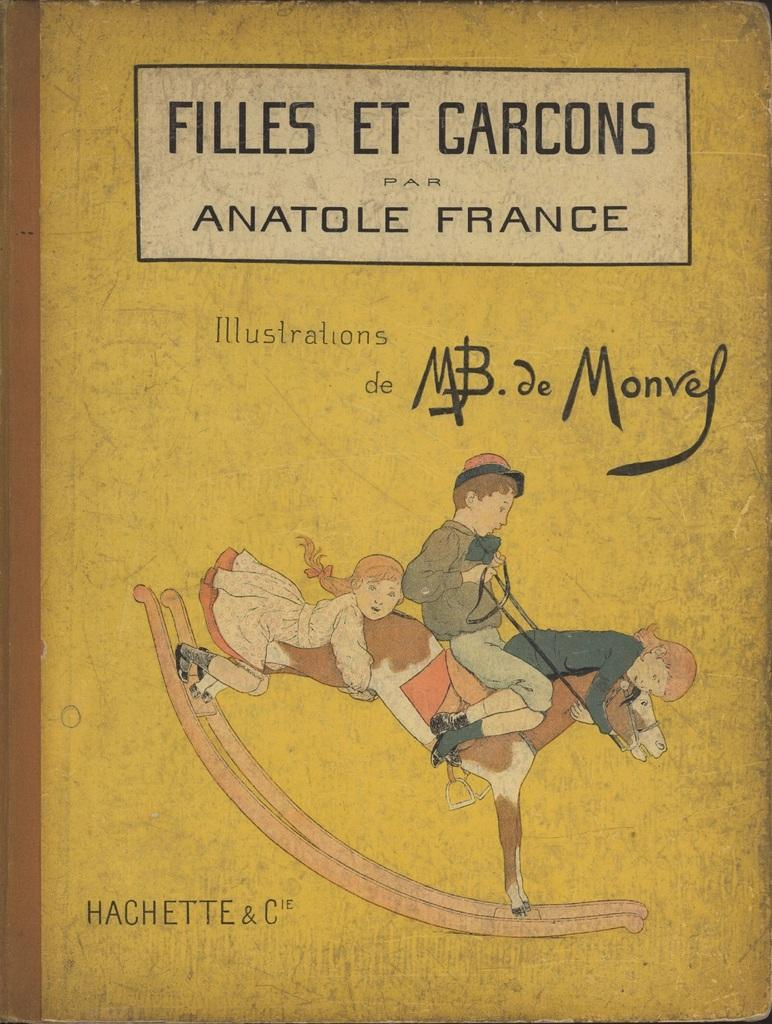<image>
Provide a brief description of the given image. Filles et garcons par anatole france book illustrations de mb de monvey 